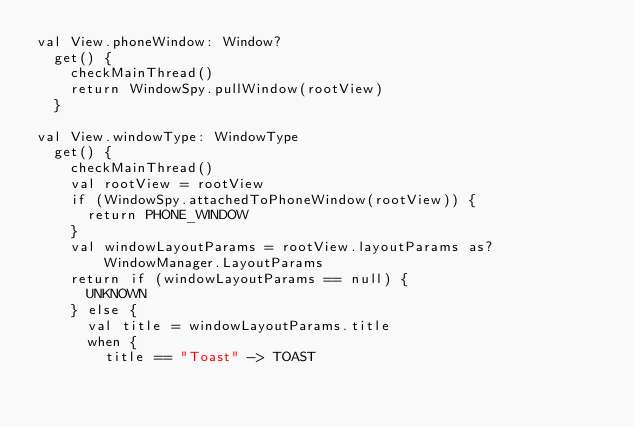Convert code to text. <code><loc_0><loc_0><loc_500><loc_500><_Kotlin_>val View.phoneWindow: Window?
  get() {
    checkMainThread()
    return WindowSpy.pullWindow(rootView)
  }

val View.windowType: WindowType
  get() {
    checkMainThread()
    val rootView = rootView
    if (WindowSpy.attachedToPhoneWindow(rootView)) {
      return PHONE_WINDOW
    }
    val windowLayoutParams = rootView.layoutParams as? WindowManager.LayoutParams
    return if (windowLayoutParams == null) {
      UNKNOWN
    } else {
      val title = windowLayoutParams.title
      when {
        title == "Toast" -> TOAST</code> 